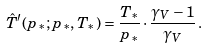<formula> <loc_0><loc_0><loc_500><loc_500>\hat { T } ^ { \prime } ( p _ { * } ; p _ { * } , T _ { * } ) = \frac { T _ { * } } { p _ { * } } \cdot \frac { \gamma _ { V } - 1 } { \gamma _ { V } } \, .</formula> 